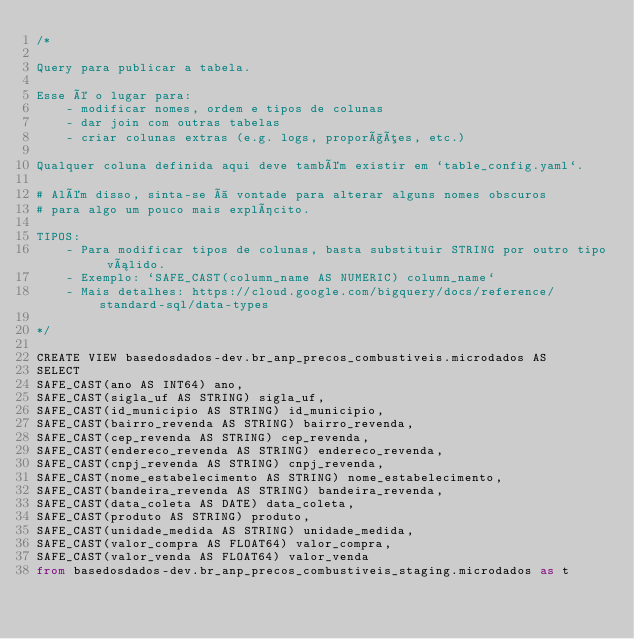<code> <loc_0><loc_0><loc_500><loc_500><_SQL_>/*

Query para publicar a tabela.

Esse é o lugar para:
    - modificar nomes, ordem e tipos de colunas
    - dar join com outras tabelas
    - criar colunas extras (e.g. logs, proporções, etc.)

Qualquer coluna definida aqui deve também existir em `table_config.yaml`.

# Além disso, sinta-se à vontade para alterar alguns nomes obscuros
# para algo um pouco mais explícito.

TIPOS:
    - Para modificar tipos de colunas, basta substituir STRING por outro tipo válido.
    - Exemplo: `SAFE_CAST(column_name AS NUMERIC) column_name`
    - Mais detalhes: https://cloud.google.com/bigquery/docs/reference/standard-sql/data-types

*/

CREATE VIEW basedosdados-dev.br_anp_precos_combustiveis.microdados AS
SELECT 
SAFE_CAST(ano AS INT64) ano,
SAFE_CAST(sigla_uf AS STRING) sigla_uf,
SAFE_CAST(id_municipio AS STRING) id_municipio,
SAFE_CAST(bairro_revenda AS STRING) bairro_revenda,
SAFE_CAST(cep_revenda AS STRING) cep_revenda,
SAFE_CAST(endereco_revenda AS STRING) endereco_revenda,
SAFE_CAST(cnpj_revenda AS STRING) cnpj_revenda,
SAFE_CAST(nome_estabelecimento AS STRING) nome_estabelecimento,
SAFE_CAST(bandeira_revenda AS STRING) bandeira_revenda,
SAFE_CAST(data_coleta AS DATE) data_coleta,
SAFE_CAST(produto AS STRING) produto,
SAFE_CAST(unidade_medida AS STRING) unidade_medida,
SAFE_CAST(valor_compra AS FLOAT64) valor_compra,
SAFE_CAST(valor_venda AS FLOAT64) valor_venda
from basedosdados-dev.br_anp_precos_combustiveis_staging.microdados as t</code> 